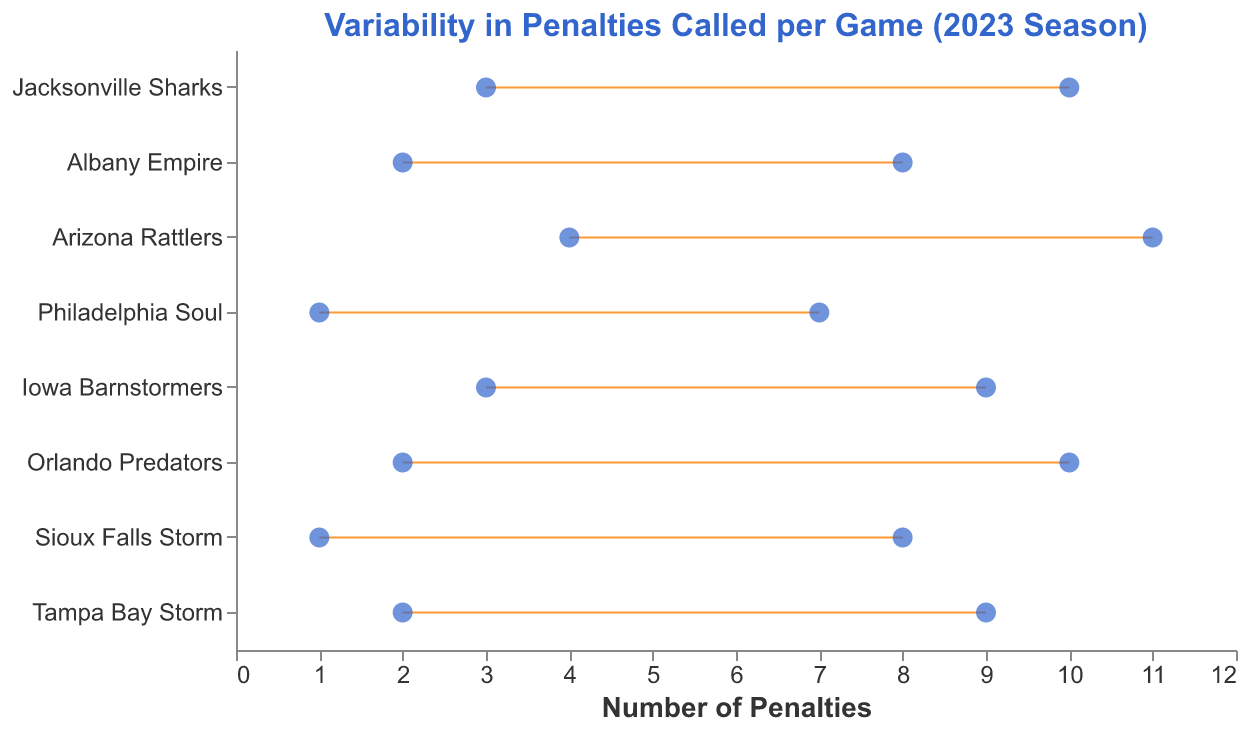What is the minimum number of penalties called for the Jacksonville Sharks? To find the minimum number of penalties called for the Jacksonville Sharks, look at the "MinPenalties" value next to the team name.
Answer: 3 What is the range of penalties for the Philadelphia Soul? Calculate the range by subtracting the minimum number of penalties (MinPenalties) from the maximum number of penalties (MaxPenalties) for the Philadelphia Soul.
Answer: 6 Which team has the highest maximum number of penalties called? Identify the team with the highest value for MaxPenalties by comparing across all teams.
Answer: Arizona Rattlers Which team has the lowest minimum number of penalties called per game? Identify the team with the lowest value for MinPenalties by comparing across all teams.
Answer: Philadelphia Soul How does the range of penalties called per game between the Tampa Bay Storm and Albany Empire compare? Calculate the range for both teams by subtracting their MinPenalties from their MaxPenalties and then compare the two ranges. The range for Tampa Bay Storm is 7 (9-2), and for Albany Empire, it is 6 (8-2).
Answer: Tampa Bay Storm's range is higher by 1 What is the variability in penalties for the Orlando Predators, and how does it compare to the Sioux Falls Storm? Calculate the range of penalties for both teams and compare. For Orlando Predators, the range is 8 (10-2), and for Sioux Falls Storm, it is 7 (8-1). Orlando Predators have a range of 8, which is higher than the Sioux Falls Storm's range of 7.
Answer: Orlando Predators have a higher range by 1 Which teams have a minimum number of penalties called at least 3 times per game? Identify teams whose MinPenalties value is 3 or higher by comparing the MinPenalties value for each team. The teams are Jacksonville Sharks, Arizona Rattlers, and Iowa Barnstormers.
Answer: Jacksonville Sharks, Arizona Rattlers, Iowa Barnstormers What is the range of penalties for the Albany Empire? Calculate by subtracting the minimum number of penalties (MinPenalties) from the maximum number of penalties (MaxPenalties) for the Albany Empire.
Answer: 6 How many teams have a maximum number of penalties called per game greater than or equal to 9? Count the number of teams whose MaxPenalties value is 9 or higher by examining the MaxPenalties for each. The teams are Jacksonville Sharks, Arizona Rattlers, Iowa Barnstormers, Orlando Predators, and Tampa Bay Storm.
Answer: 5 What is the difference in the maximum number of penalties between the Arizona Rattlers and Sioux Falls Storm? Subtract the MaxPenalties of Sioux Falls Storm from the MaxPenalties of Arizona Rattlers. For Arizona Rattlers, it's 11, and for Sioux Falls Storm, it's 8. The difference is 11 - 8.
Answer: 3 